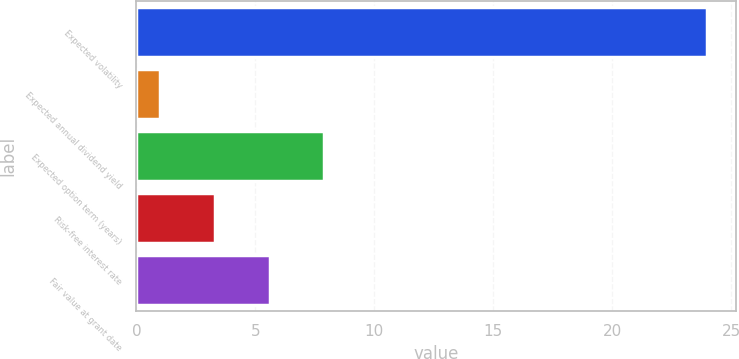<chart> <loc_0><loc_0><loc_500><loc_500><bar_chart><fcel>Expected volatility<fcel>Expected annual dividend yield<fcel>Expected option term (years)<fcel>Risk-free interest rate<fcel>Fair value at grant date<nl><fcel>24<fcel>1<fcel>7.9<fcel>3.3<fcel>5.6<nl></chart> 